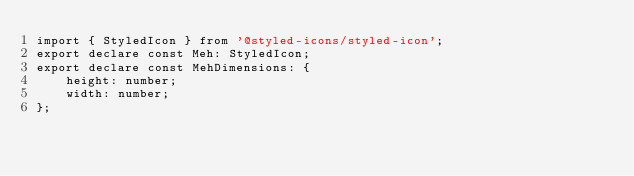<code> <loc_0><loc_0><loc_500><loc_500><_TypeScript_>import { StyledIcon } from '@styled-icons/styled-icon';
export declare const Meh: StyledIcon;
export declare const MehDimensions: {
    height: number;
    width: number;
};
</code> 